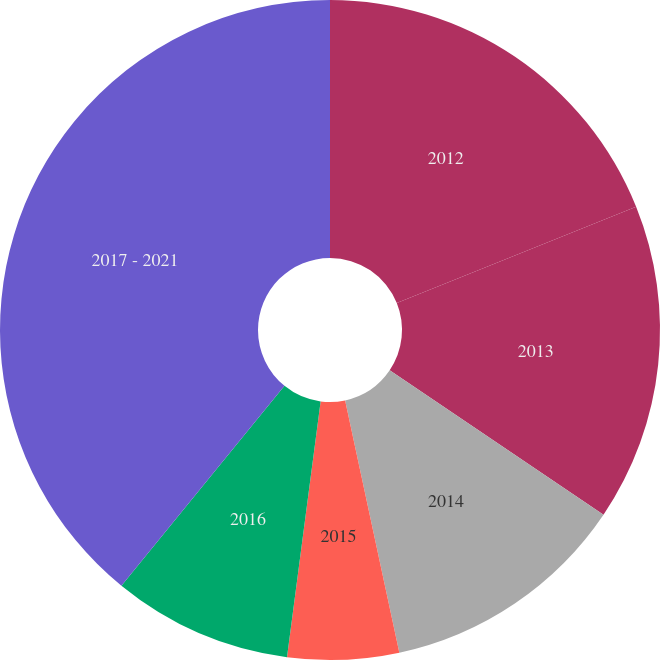Convert chart. <chart><loc_0><loc_0><loc_500><loc_500><pie_chart><fcel>2012<fcel>2013<fcel>2014<fcel>2015<fcel>2016<fcel>2017 - 2021<nl><fcel>18.91%<fcel>15.54%<fcel>12.18%<fcel>5.45%<fcel>8.81%<fcel>39.11%<nl></chart> 